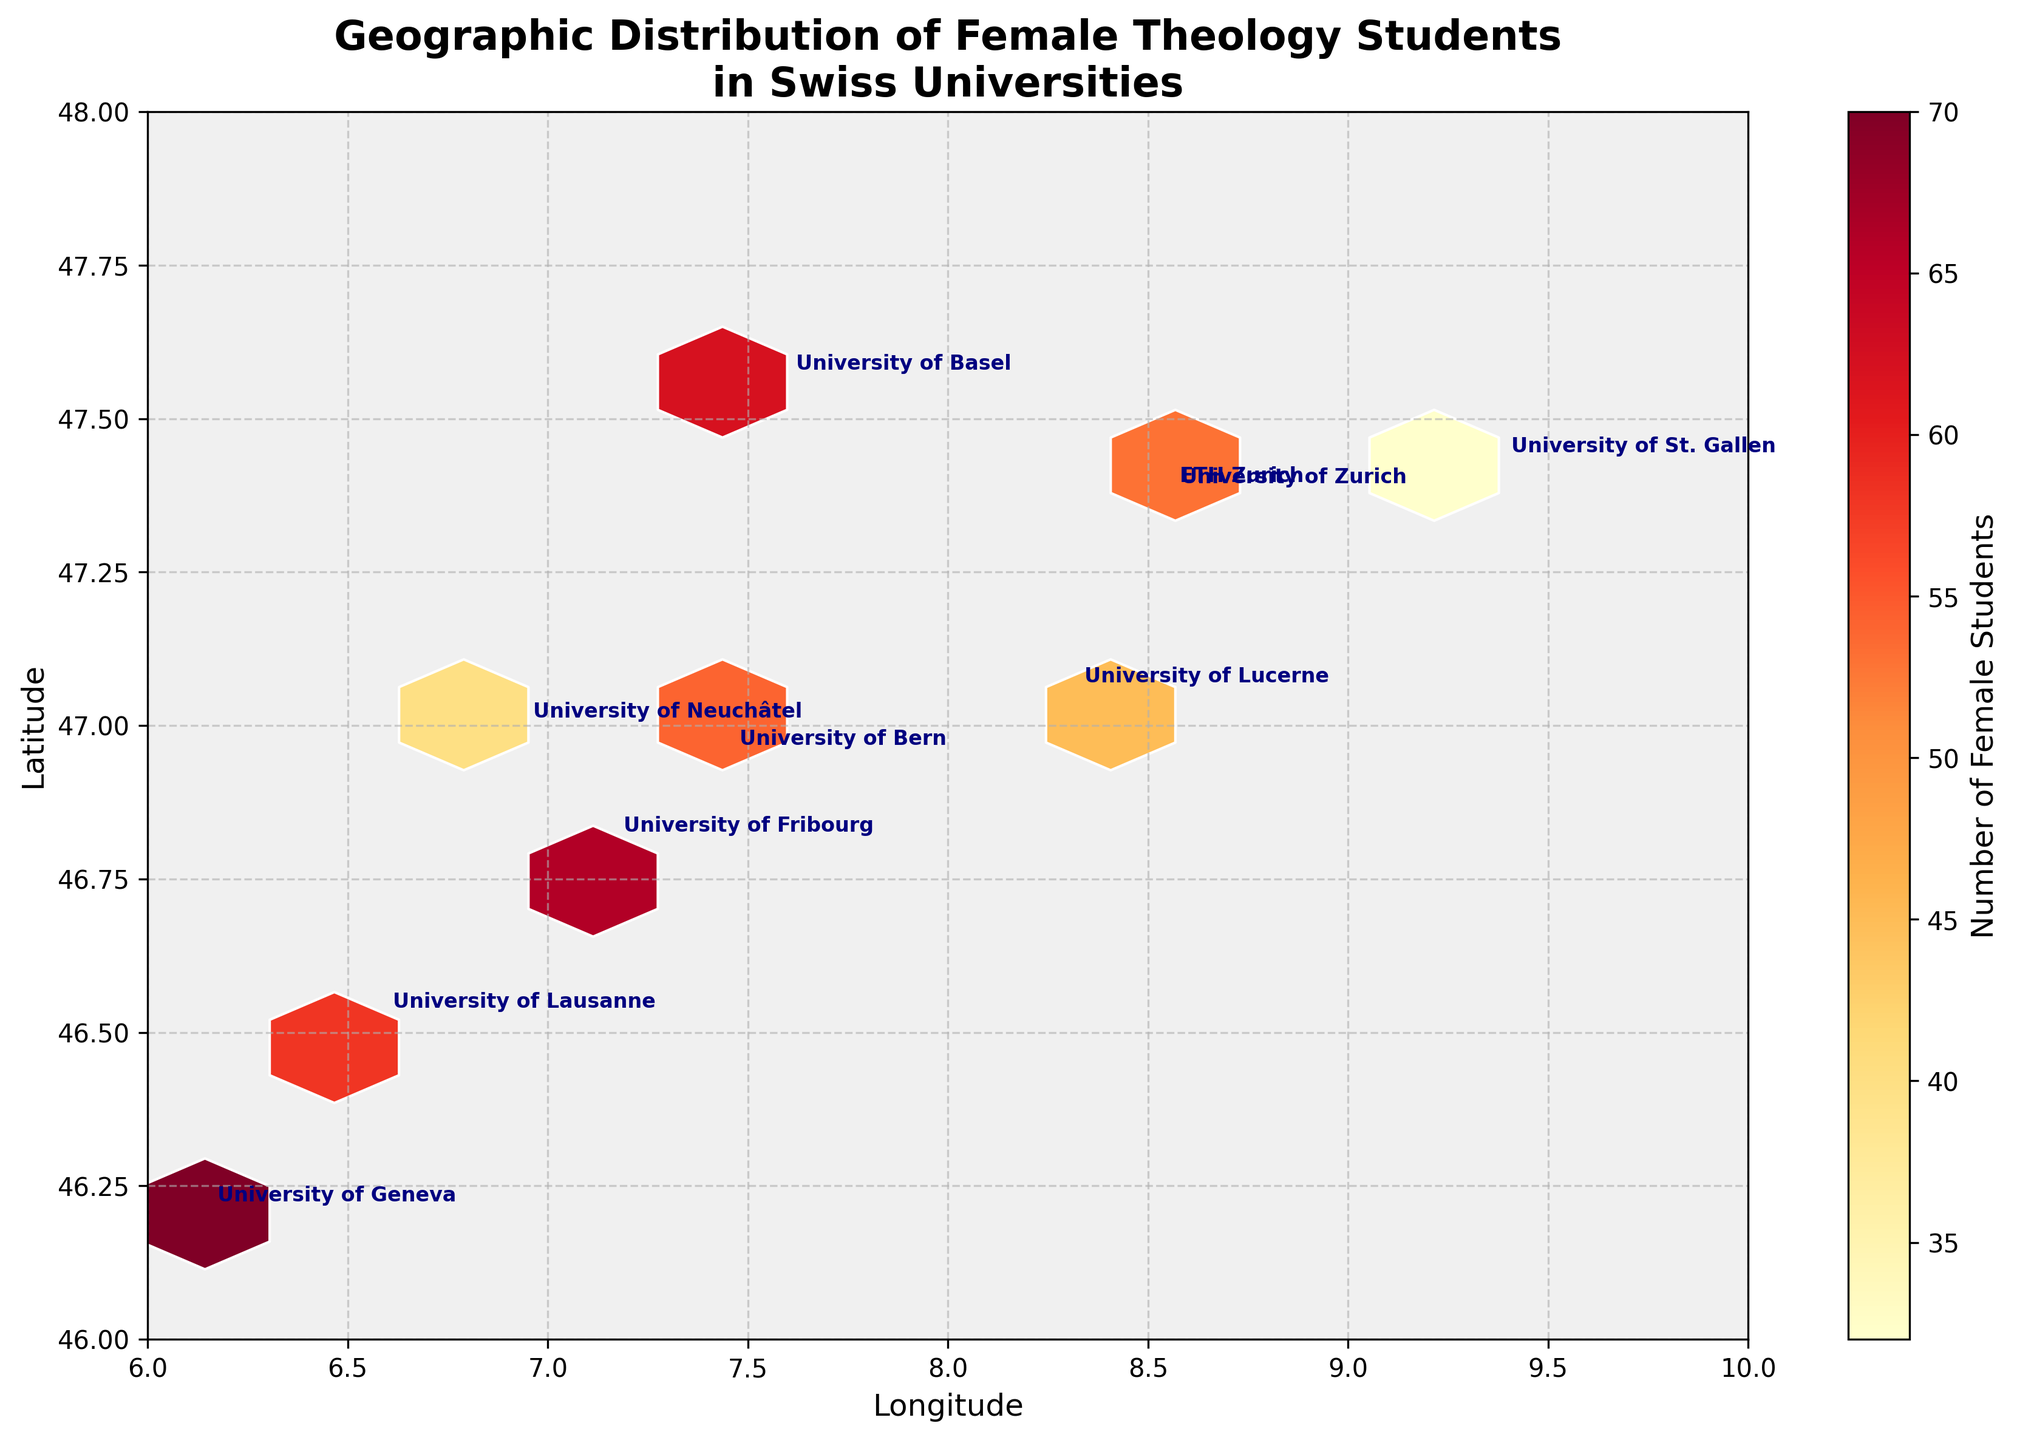How many universities are shown on the plot? Count the number of unique annotations or data points on the plot which correspond to the universities.
Answer: 10 What is the title of the plot? Read the title text displayed at the top of the plot.
Answer: Geographic Distribution of Female Theology Students in Swiss Universities Which university has the highest number of female theology students? Look at the color intensity in the hexbin plot and find the university annotation closest to the darkest hexbin. The color bar indicates dark signifies a higher number of students.
Answer: University of Zurich What is the average number of female theology students across all universities? Sum the number of female students from all universities and divide by the number of universities: (78+62+54+45+70+58+66+32+28+40)/10.
Answer: 53.3 Which universities are located approximately at the same latitude (47°)? Identify the annotations for universities with latitudes close to 47° on the y-axis of the plot.
Answer: University of Zurich, University of Lucerne, ETH Zurich, University of St. Gallen How does the number of female theology students at the University of Geneva compare to the University of Lausanne? Find the exact values of female students for both universities from their annotations and compare: Geneva (70) and Lausanne (58).
Answer: University of Geneva has more female students What program is offered at the University of Fribourg? Look at the annotation for the University of Fribourg on the plot to find the associated program.
Answer: Pastoral Theology Describe the geographic area with the highest concentration of female theology students. Locate the darkest hexbin cell and identify the corresponding geographic coordinates from the axis, then identify the nearby university annotations.
Answer: Area around Zurich What is the longitude range covered by the universities? Determine the minimum and maximum longitude values visible on the x-axis and between which the university annotations are placed.
Answer: 6.1432 to 9.3767 Which university lies at the westernmost point on the plot? Find the university annotation with the smallest longitude value on the x-axis.
Answer: University of Geneva 